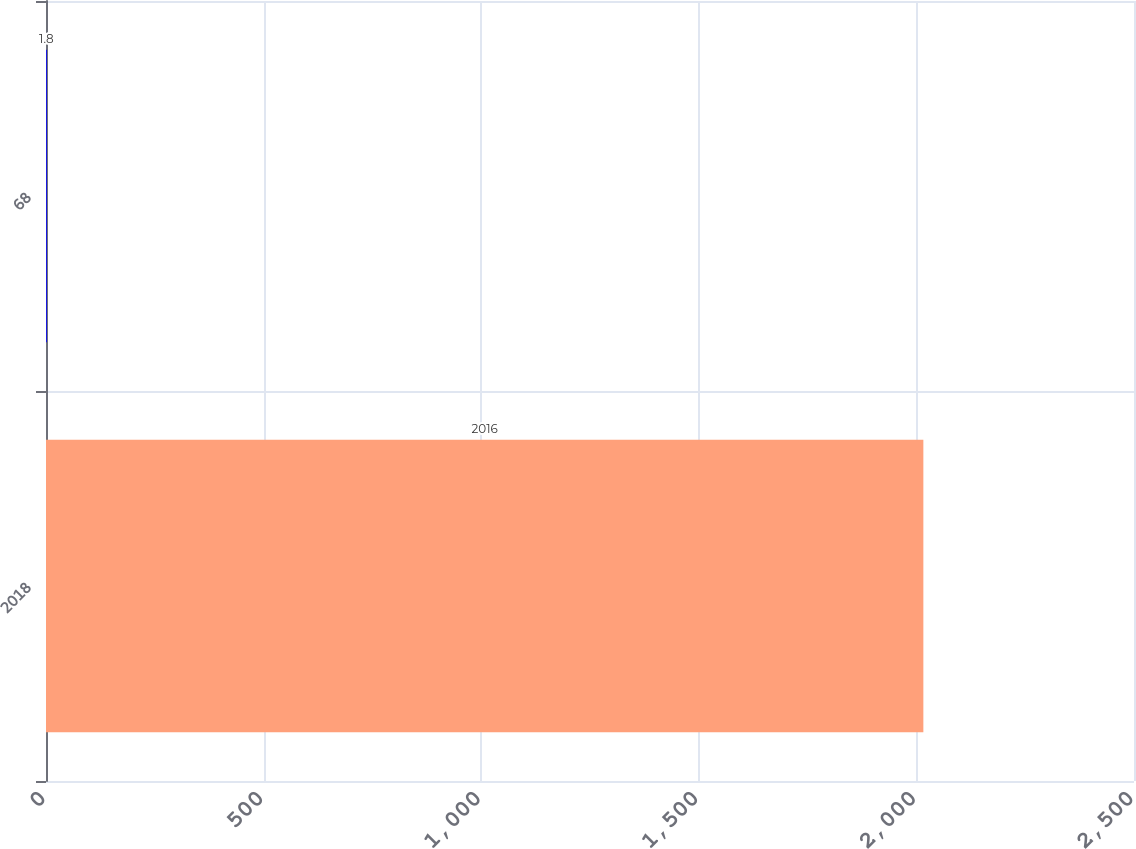<chart> <loc_0><loc_0><loc_500><loc_500><bar_chart><fcel>2018<fcel>68<nl><fcel>2016<fcel>1.8<nl></chart> 